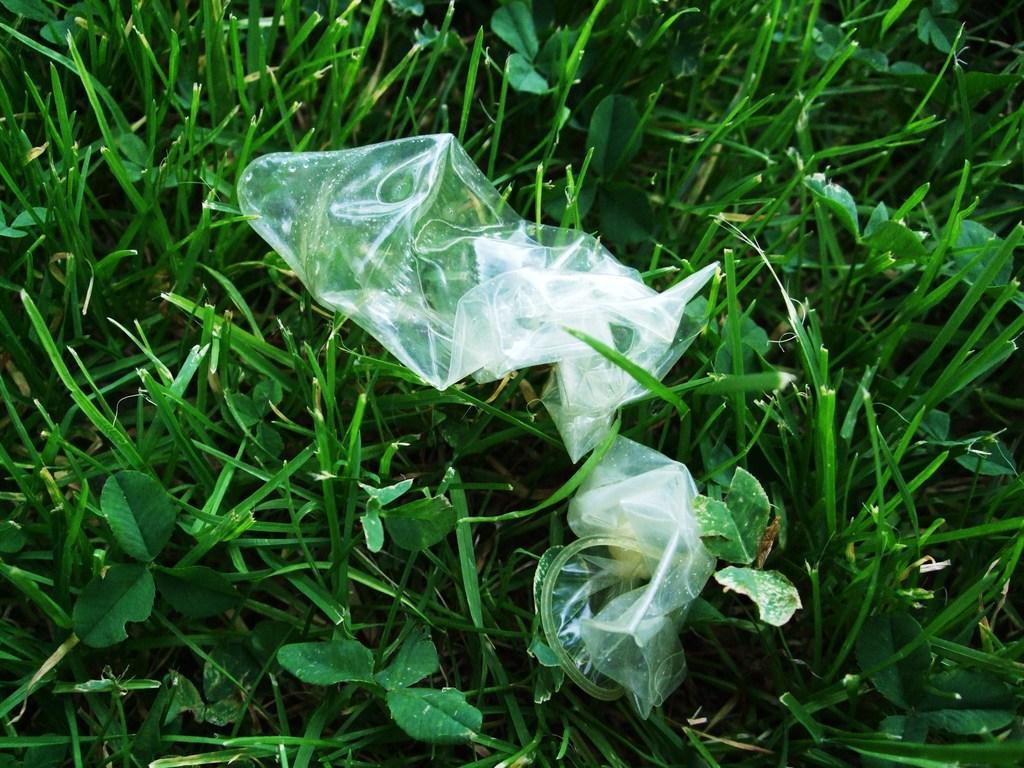Please provide a concise description of this image. In this image we can see objects on the grass. 